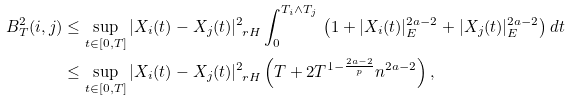Convert formula to latex. <formula><loc_0><loc_0><loc_500><loc_500>B _ { T } ^ { 2 } ( i , j ) & \leq \sup _ { t \in [ 0 , T ] } | X _ { i } ( t ) - X _ { j } ( t ) | _ { \ r H } ^ { 2 } \int _ { 0 } ^ { T _ { i } \wedge T _ { j } } \, \left ( 1 + | X _ { i } ( t ) | _ { E } ^ { 2 a - 2 } + | X _ { j } ( t ) | _ { E } ^ { 2 a - 2 } \right ) d t \\ & \leq \sup _ { t \in [ 0 , T ] } | X _ { i } ( t ) - X _ { j } ( t ) | _ { \ r H } ^ { 2 } \left ( T + 2 T ^ { 1 - \frac { 2 a - 2 } p } n ^ { 2 a - 2 } \right ) ,</formula> 